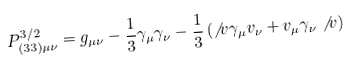<formula> <loc_0><loc_0><loc_500><loc_500>P ^ { 3 / 2 } _ { ( 3 3 ) \mu \nu } = g _ { \mu \nu } - \frac { 1 } { 3 } \gamma _ { \mu } \gamma _ { \nu } - \frac { 1 } { 3 } \left ( \not \, { v } \gamma _ { \mu } v _ { \nu } + v _ { \mu } \gamma _ { \nu } \not \, { v } \right )</formula> 